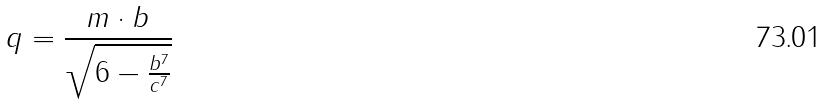<formula> <loc_0><loc_0><loc_500><loc_500>q = \frac { m \cdot b } { \sqrt { 6 - \frac { b ^ { 7 } } { c ^ { 7 } } } }</formula> 